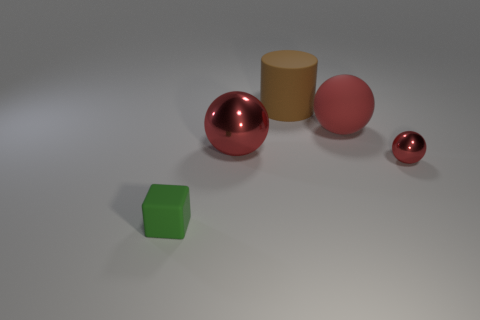Are there any gray metallic cylinders that have the same size as the matte block?
Provide a short and direct response. No. Is the number of cyan cylinders less than the number of green cubes?
Offer a very short reply. Yes. What shape is the large thing behind the large red ball on the right side of the sphere that is left of the big brown rubber thing?
Your response must be concise. Cylinder. What number of things are matte objects on the right side of the matte cube or large shiny things that are in front of the large red matte object?
Provide a short and direct response. 3. Are there any small rubber blocks to the right of the red rubber ball?
Your answer should be compact. No. How many objects are either red things in front of the big rubber sphere or cyan spheres?
Make the answer very short. 2. How many brown things are matte cylinders or cubes?
Keep it short and to the point. 1. What number of other things are there of the same color as the tiny sphere?
Make the answer very short. 2. Are there fewer red balls that are behind the brown cylinder than yellow matte cubes?
Your answer should be compact. No. The tiny object that is behind the thing in front of the metal object that is on the right side of the brown rubber thing is what color?
Keep it short and to the point. Red. 